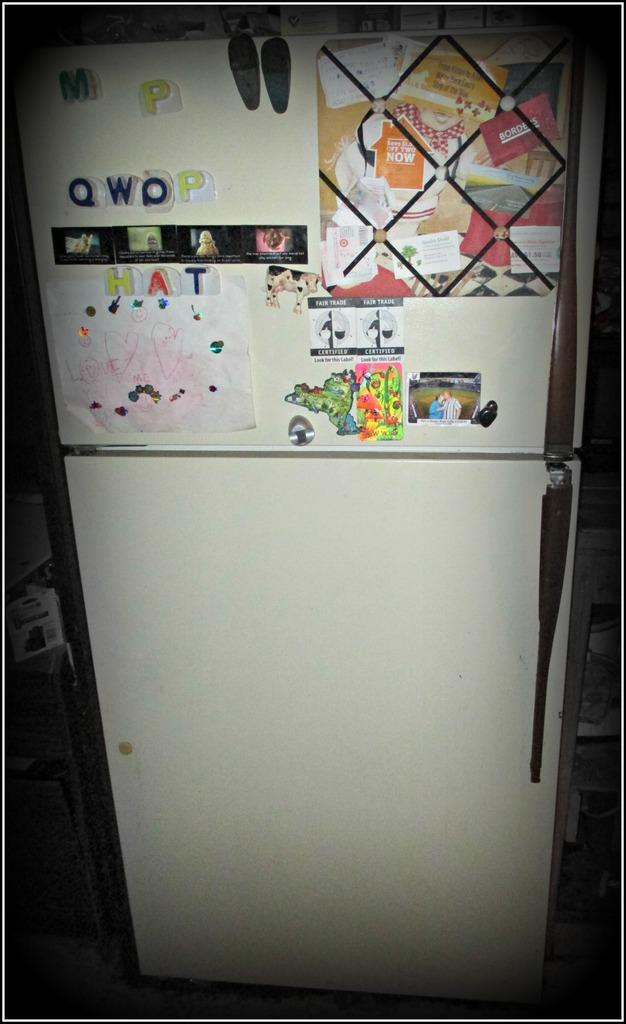<image>
Share a concise interpretation of the image provided. A white refrigerator with the word hat spelled out with plastic magnets. 